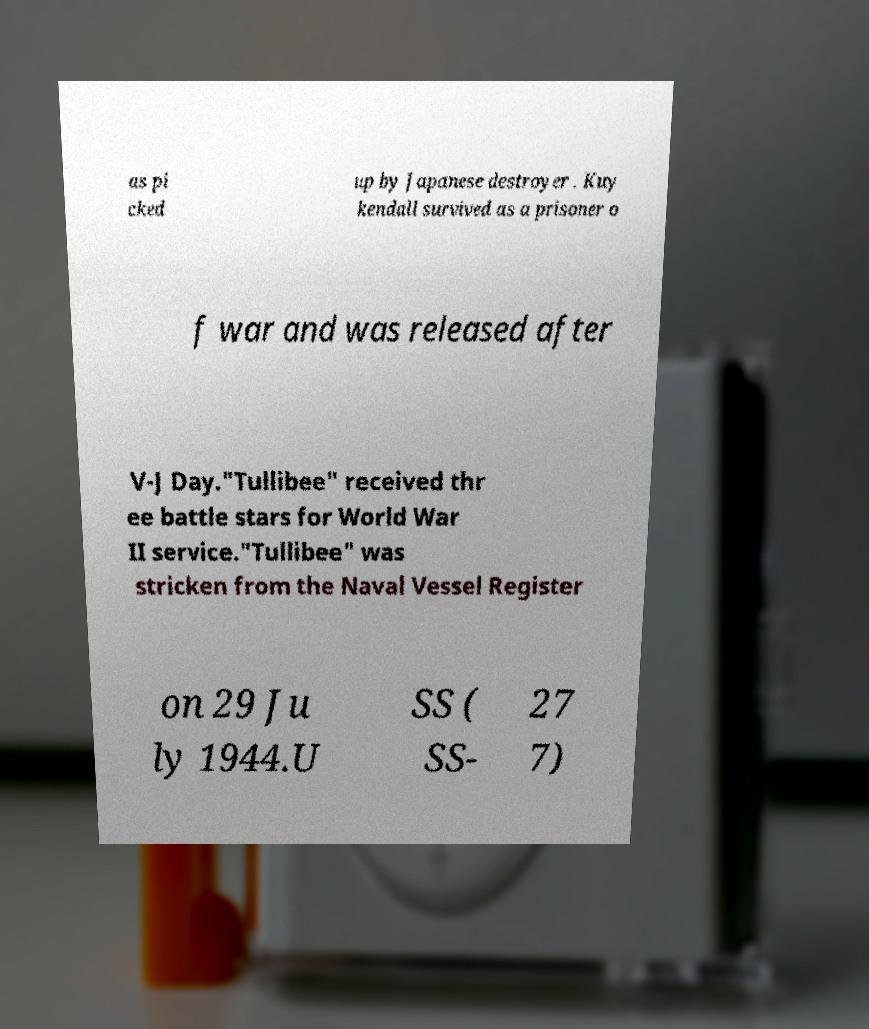Could you assist in decoding the text presented in this image and type it out clearly? as pi cked up by Japanese destroyer . Kuy kendall survived as a prisoner o f war and was released after V-J Day."Tullibee" received thr ee battle stars for World War II service."Tullibee" was stricken from the Naval Vessel Register on 29 Ju ly 1944.U SS ( SS- 27 7) 